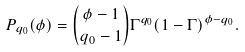<formula> <loc_0><loc_0><loc_500><loc_500>P _ { q _ { 0 } } ( \phi ) = { \phi - 1 \choose q _ { 0 } - 1 } \Gamma ^ { q _ { 0 } } ( 1 - \Gamma ) ^ { \phi - q _ { 0 } } .</formula> 